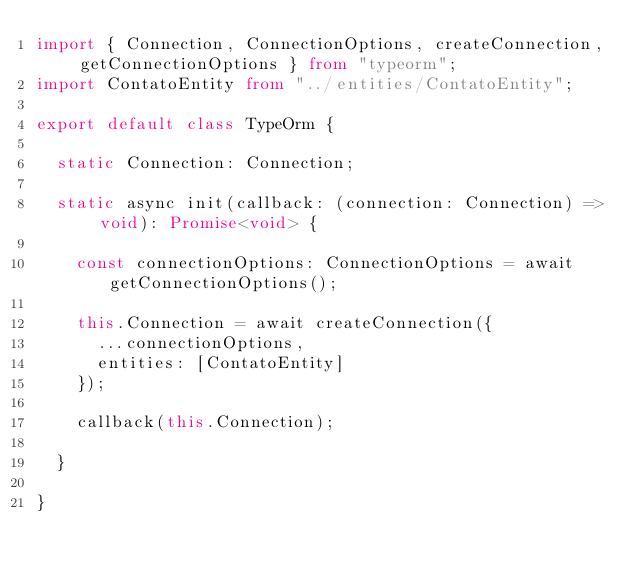<code> <loc_0><loc_0><loc_500><loc_500><_TypeScript_>import { Connection, ConnectionOptions, createConnection, getConnectionOptions } from "typeorm";
import ContatoEntity from "../entities/ContatoEntity";

export default class TypeOrm {

  static Connection: Connection;

  static async init(callback: (connection: Connection) => void): Promise<void> {

    const connectionOptions: ConnectionOptions = await getConnectionOptions();

    this.Connection = await createConnection({
      ...connectionOptions,
      entities: [ContatoEntity]
    });

    callback(this.Connection);

  }

}
</code> 